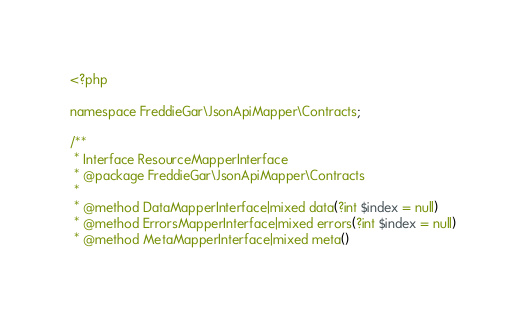<code> <loc_0><loc_0><loc_500><loc_500><_PHP_><?php

namespace FreddieGar\JsonApiMapper\Contracts;

/**
 * Interface ResourceMapperInterface
 * @package FreddieGar\JsonApiMapper\Contracts
 *
 * @method DataMapperInterface|mixed data(?int $index = null)
 * @method ErrorsMapperInterface|mixed errors(?int $index = null)
 * @method MetaMapperInterface|mixed meta()</code> 